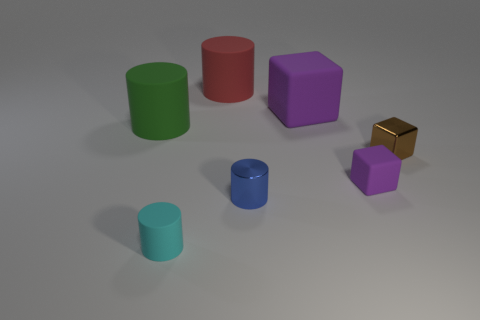What number of other things are there of the same color as the tiny rubber cube?
Provide a succinct answer. 1. Are there more balls than tiny blue cylinders?
Your response must be concise. No. Do the cyan object and the purple rubber object on the left side of the tiny purple block have the same size?
Give a very brief answer. No. What is the color of the rubber block that is in front of the small brown shiny thing?
Provide a short and direct response. Purple. How many yellow things are small metallic blocks or small things?
Provide a short and direct response. 0. The big block is what color?
Keep it short and to the point. Purple. Are there any other things that have the same material as the green cylinder?
Provide a succinct answer. Yes. Is the number of red objects that are on the right side of the small brown thing less than the number of metal cylinders that are to the left of the blue cylinder?
Keep it short and to the point. No. There is a matte object that is both right of the big red rubber cylinder and behind the tiny purple object; what shape is it?
Provide a short and direct response. Cube. What number of tiny blue shiny things have the same shape as the tiny brown thing?
Offer a very short reply. 0. 